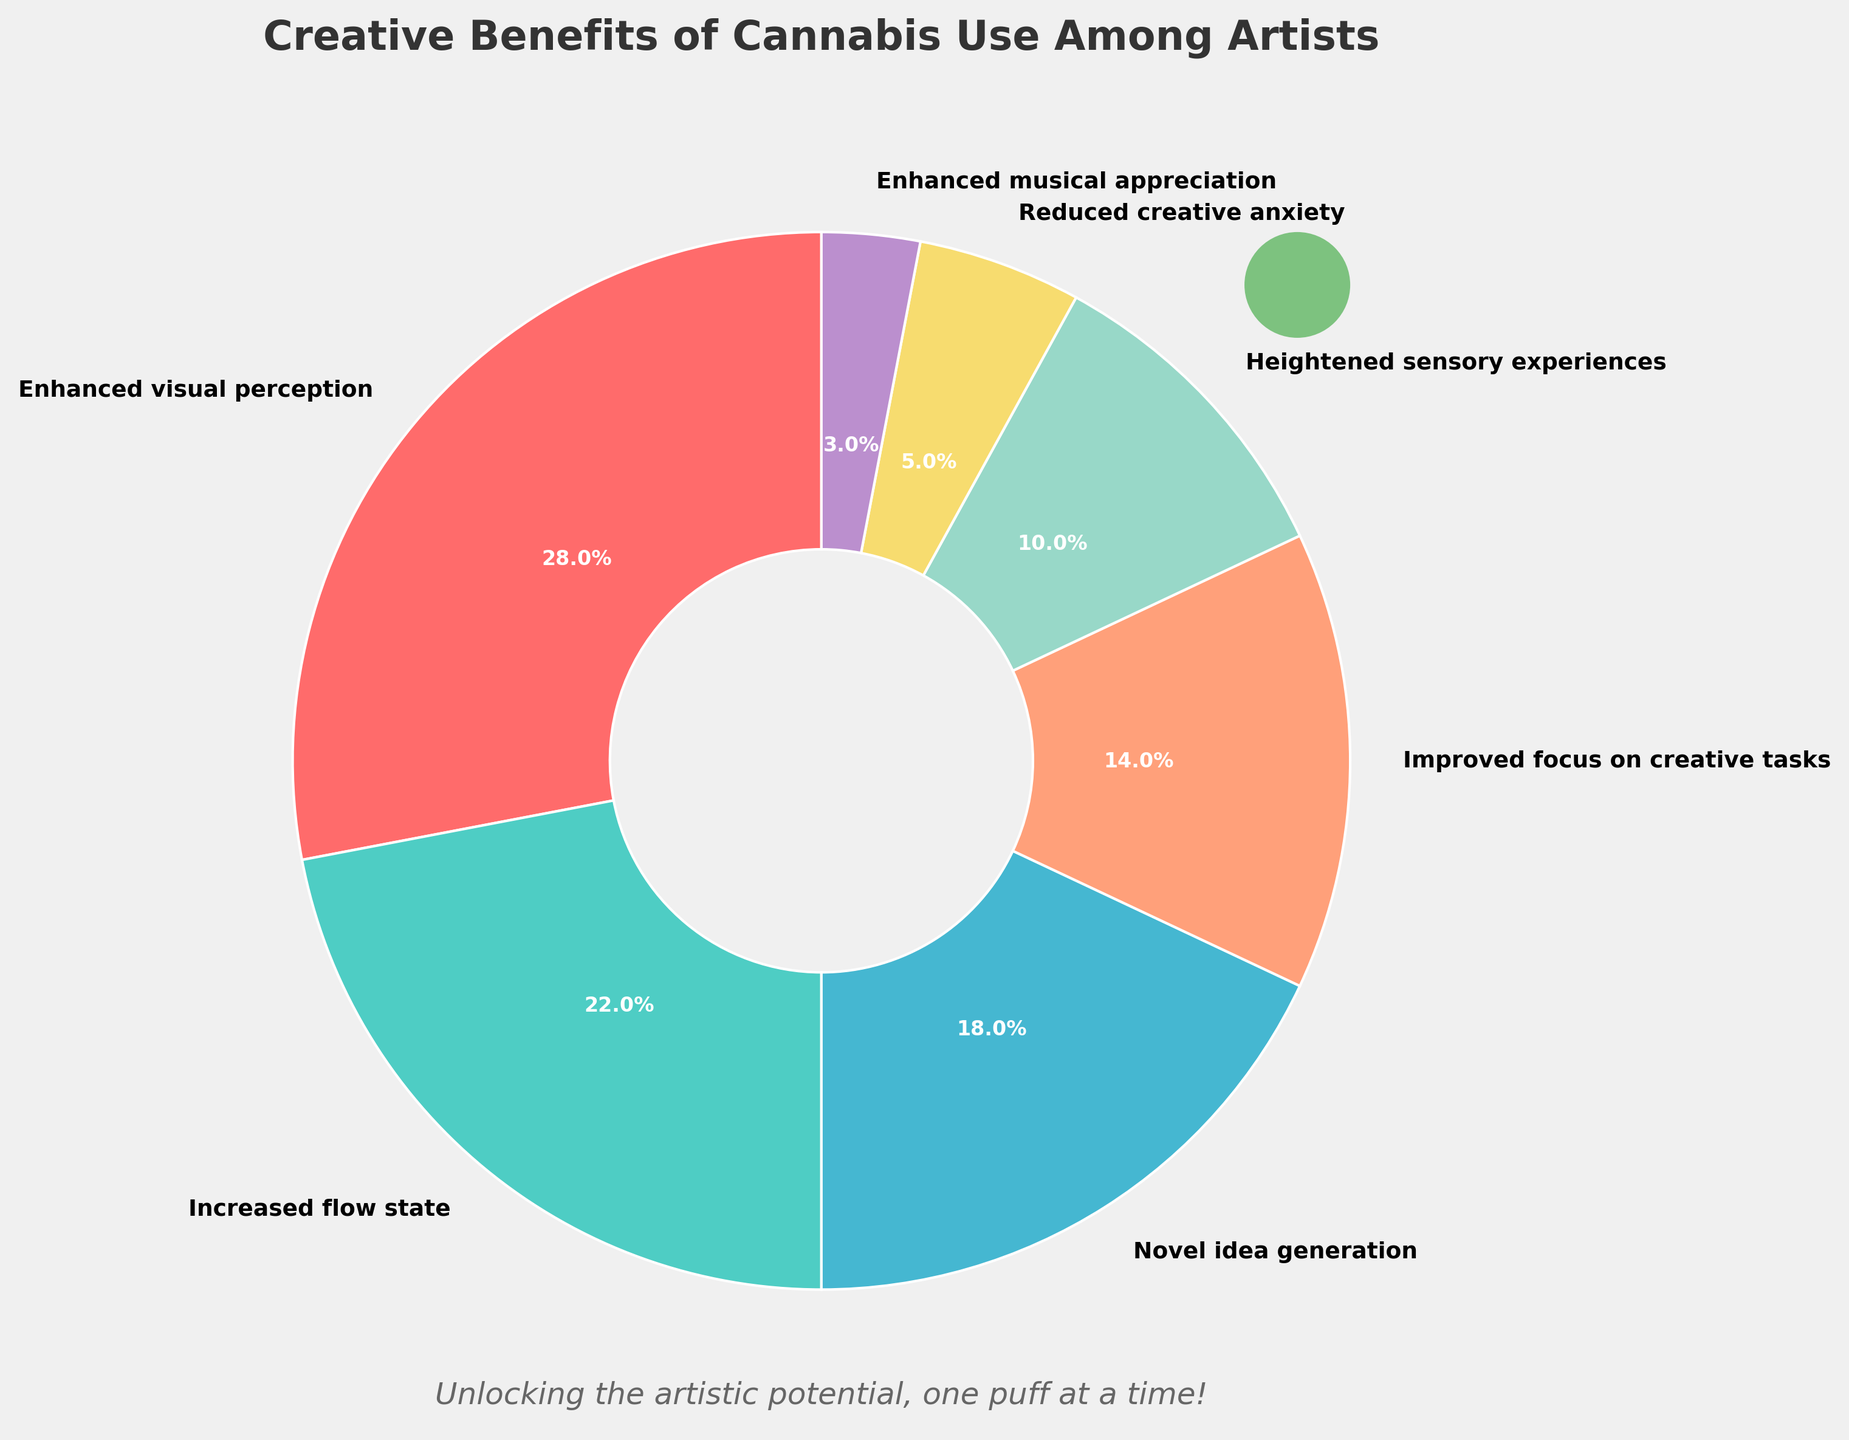Which category has the highest reported creative benefit from cannabis use? By examining the pie chart, we can see that "Enhanced visual perception" occupies the largest section of the pie chart.
Answer: Enhanced visual perception Which two categories together make up exactly half of the reported benefits? Adding the percentages of the two largest categories, "Enhanced visual perception" (28%) and "Increased flow state" (22%), which give 28 + 22 = 50%.
Answer: Enhanced visual perception and Increased flow state What is the difference in the percentage of reported benefits between "Enhanced visual perception" and "Novel idea generation"? From the chart, "Enhanced visual perception" is 28% and "Novel idea generation" is 18%. The difference is 28 - 18 = 10%.
Answer: 10% Which reported benefit has the smallest percentage and what is it? From the pie chart, "Enhanced musical appreciation" is the smallest segment.
Answer: Enhanced musical appreciation, 3% What are the combined percentages of the bottom three reported benefits? Sum the percentages of "Heightened sensory experiences" (10%), "Reduced creative anxiety" (5%), and "Enhanced musical appreciation" (3%): 10 + 5 + 3 = 18%.
Answer: 18% How much more percentage does "Improved focus on creative tasks" have compared to "Heightened sensory experiences"? "Improved focus on creative tasks" is 14% and "Heightened sensory experiences" is 10%. The difference is 14 - 10 = 4%.
Answer: 4% What is the median percentage value of all the reported benefits? Arrange the percentages in ascending order: 3, 5, 10, 14, 18, 22, 28. The median value, which is the middle number in this ordered list, is 14.
Answer: 14% Which benefit has a higher percentage: "Improved focus on creative tasks" or "Novel idea generation"? By examining the chart, "Novel idea generation" has a higher percentage (18%) compared to "Improved focus on creative tasks" (14%).
Answer: Novel idea generation 